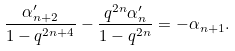<formula> <loc_0><loc_0><loc_500><loc_500>\frac { \alpha _ { n + 2 } ^ { \prime } } { 1 - q ^ { 2 n + 4 } } - \frac { q ^ { 2 n } \alpha _ { n } ^ { \prime } } { 1 - q ^ { 2 n } } = - \alpha _ { n + 1 } .</formula> 